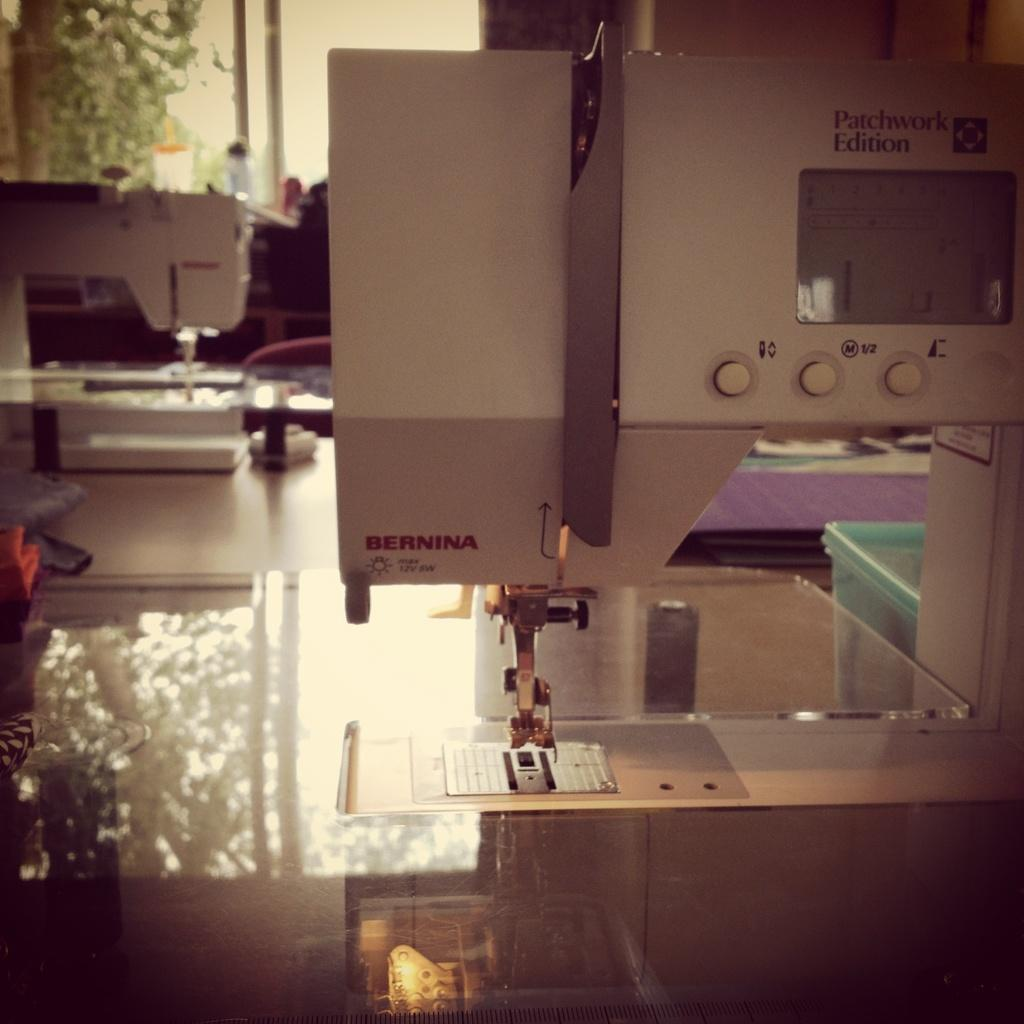What type of objects are present in the image? There are machines, glasses, a box, and a cloth in the image. What can be seen through the glasses in the image? Trees are visible through the glass. What type of wood is used to construct the machines in the image? There is no mention of wood or the construction materials of the machines in the image. What type of work is being done by the machines in the image? The image does not provide any information about the work being done by the machines. 